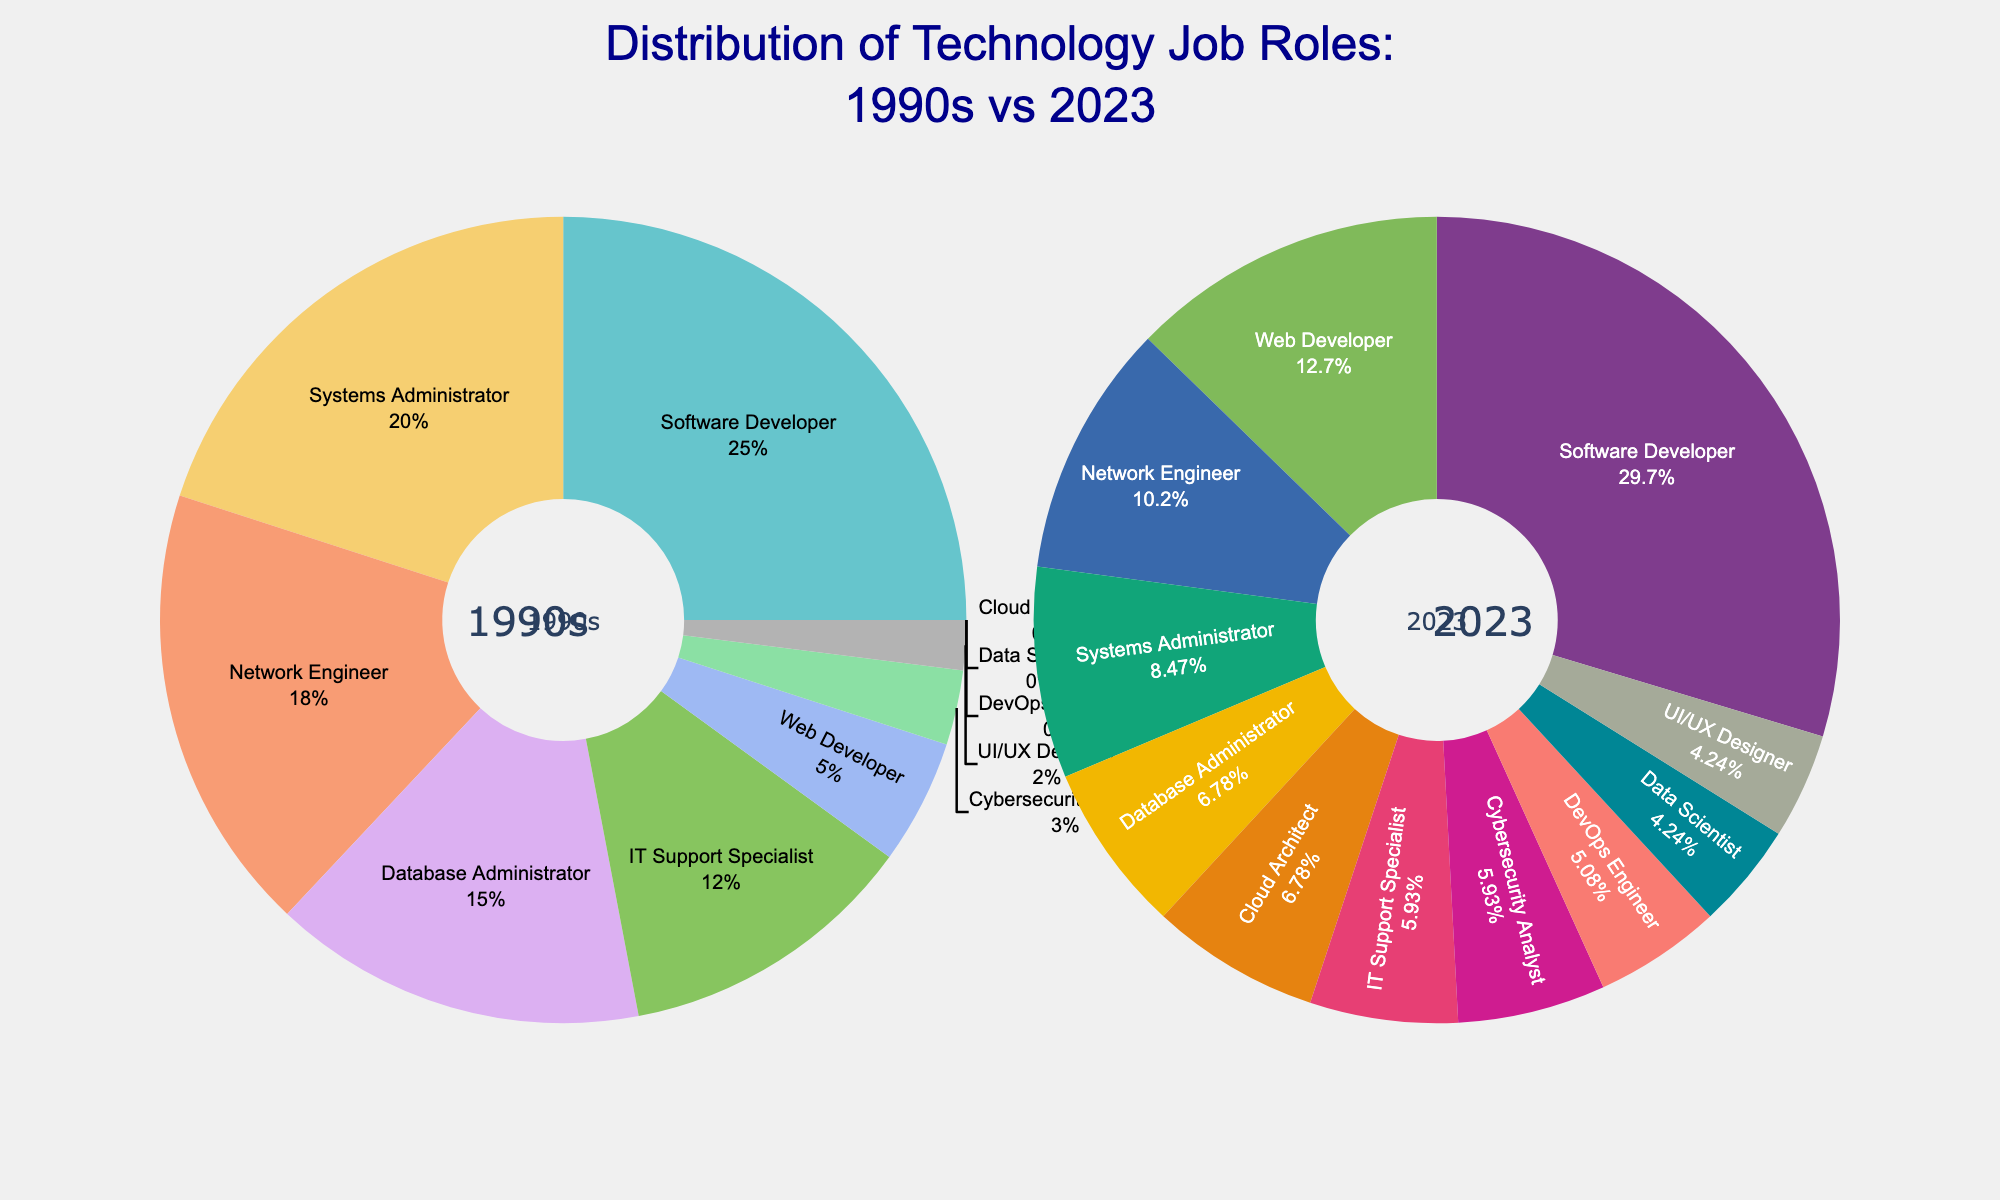What percentage of tech job roles in the 1990s were Software Developers? Locate the slice for Software Developers on the left pie chart, which represents the 1990s, and read the percentage value.
Answer: 25% Which job role saw the largest increase in percentage from the 1990s to 2023? Identify the job role with the most significant difference in its slices between the two pie charts, noting that Web Developer increased from 5% in the 1990s to 15% in 2023.
Answer: Web Developer How does the combined percentage of Systems Administrator and Network Engineer roles in the 1990s compare to their combined percentage in 2023? Add the percentages of Systems Administrator and Network Engineer in both timeframes: (20% + 18%) in the 1990s vs (10% + 12%) in 2023, then compare the sums (38% vs 22%).
Answer: 38% in the 1990s, 22% in 2023 Which job roles did not exist in the 1990s but are present in 2023? Look for job roles represented by 0% in the 1990s pie chart that have a non-zero percentage in the 2023 pie chart.
Answer: Cloud Architect, Data Scientist, DevOps Engineer What is the difference in percentage between IT Support Specialists in the 1990s and 2023? Subtract the 2023 percentage for IT Support Specialist (7%) from the 1990s percentage (12%).
Answer: 5% Which job role had the smallest presence in the 1990s, and what is its current percentage? The smallest presence in the 1990s was UI/UX Designer at 2%; check its corresponding slice in the 2023 pie chart.
Answer: UI/UX Designer, 5% What is the total percentage of new job roles introduced in 2023 that were not present in the 1990s? Sum the percentages of Cloud Architect (8%), Data Scientist (5%), and DevOps Engineer (6%).
Answer: 19% By how much has the percentage of Software Developers increased from the 1990s to 2023? Subtract the 1990s percentage of Software Developers (25%) from the 2023 percentage (35%).
Answer: 10% What is the combined percentage of job roles related to security (Cybersecurity Analyst) in the 1990s and 2023? Note the percentage for Cybersecurity Analyst in both charts and add them together: 3% (1990s) + 7% (2023).
Answer: 10% 